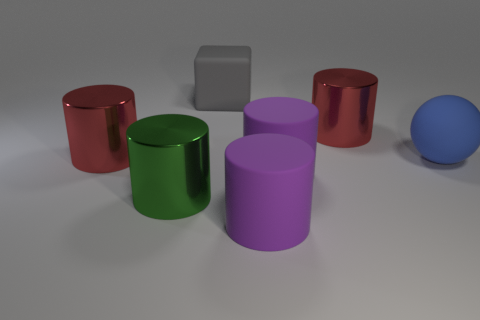Subtract all green cylinders. How many cylinders are left? 4 Subtract 1 cylinders. How many cylinders are left? 4 Subtract all green cylinders. How many cylinders are left? 4 Subtract all yellow cylinders. Subtract all red blocks. How many cylinders are left? 5 Subtract all blocks. How many objects are left? 6 Add 2 blue rubber things. How many objects exist? 9 Add 7 big gray blocks. How many big gray blocks are left? 8 Add 2 large brown blocks. How many large brown blocks exist? 2 Subtract 0 purple balls. How many objects are left? 7 Subtract all green cylinders. Subtract all big green objects. How many objects are left? 5 